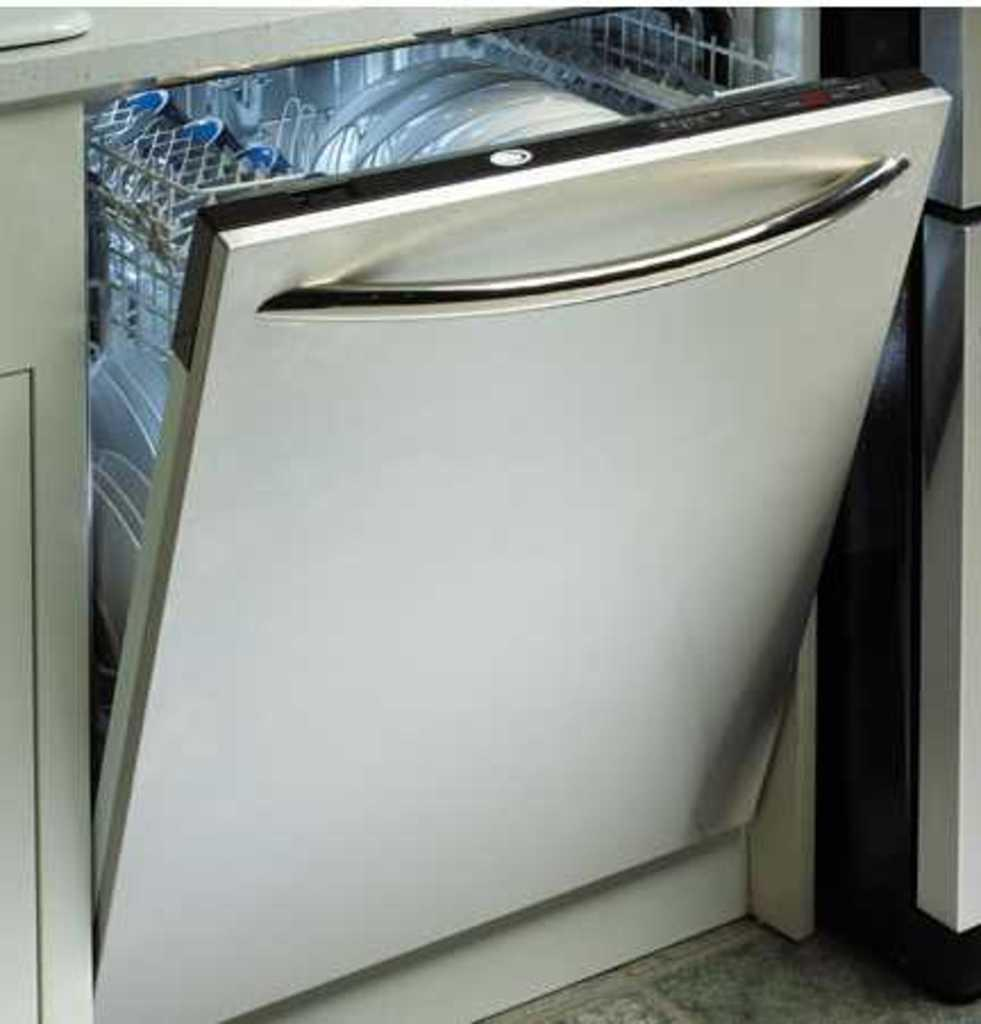What objects are visible on the shelf in the image? There are plates and utensils arranged on the shelf in the image. What feature does the shelf have? The shelf has a handle. What direction does the action take place in the image? There is no action taking place in the image, as it only shows plates and utensils arranged on a shelf. What type of smell can be detected from the image? There is no smell associated with the image, as it only shows inanimate objects. 